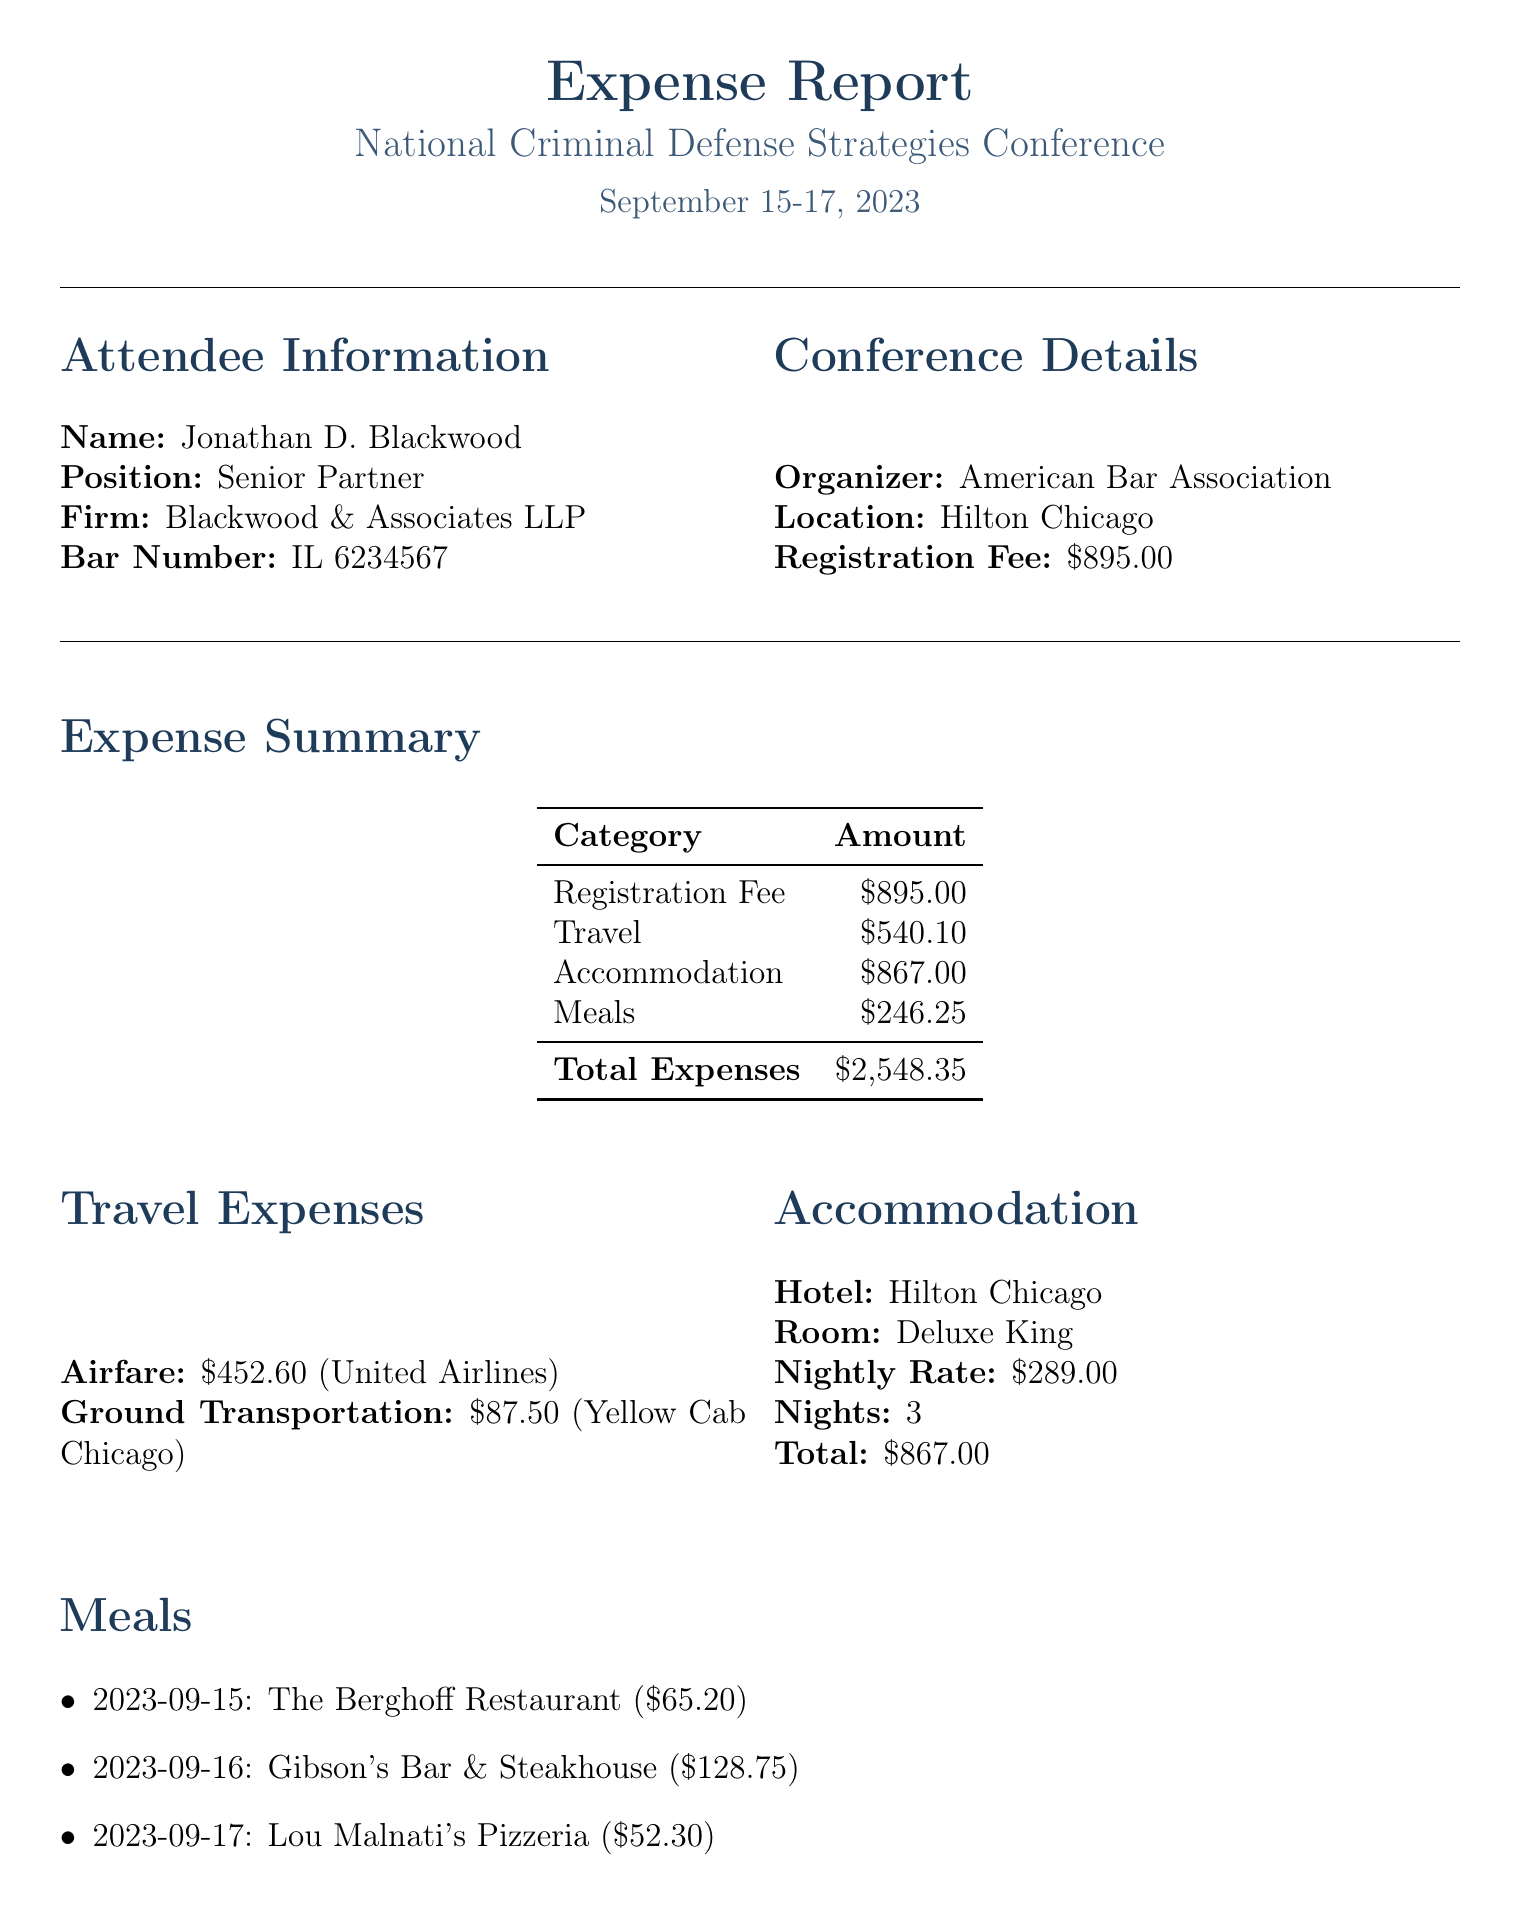What is the name of the conference? The name of the conference is prominently stated in the document's title section as "National Criminal Defense Strategies Conference."
Answer: National Criminal Defense Strategies Conference What is the registration fee? The registration fee is specifically detailed in the conference details section of the document as $895.00.
Answer: $895.00 Who is the attendee? The attendee's name is provided in the attendee information section as Jonathan D. Blackwood.
Answer: Jonathan D. Blackwood How many nights did the attendee stay? The document states the number of nights stayed in the accommodation section as 3 nights.
Answer: 3 What was the total cost of meals? The total cost of meals is summarized in the expense summary section as $246.25.
Answer: $246.25 Which hotel was used for accommodation? The hotel name is listed in the accommodation section of the document, specifically as Hilton Chicago.
Answer: Hilton Chicago What event occurred on September 16? The document lists the Gala Dinner as a networking event that occurred on September 16.
Answer: Gala Dinner How many CLE credits were earned? The document states the number of continuing legal education credits earned in the professional development section as 18.
Answer: 18 What type of ground transportation was used? The ground transportation type listed in the travel expenses section is a Taxi.
Answer: Taxi 